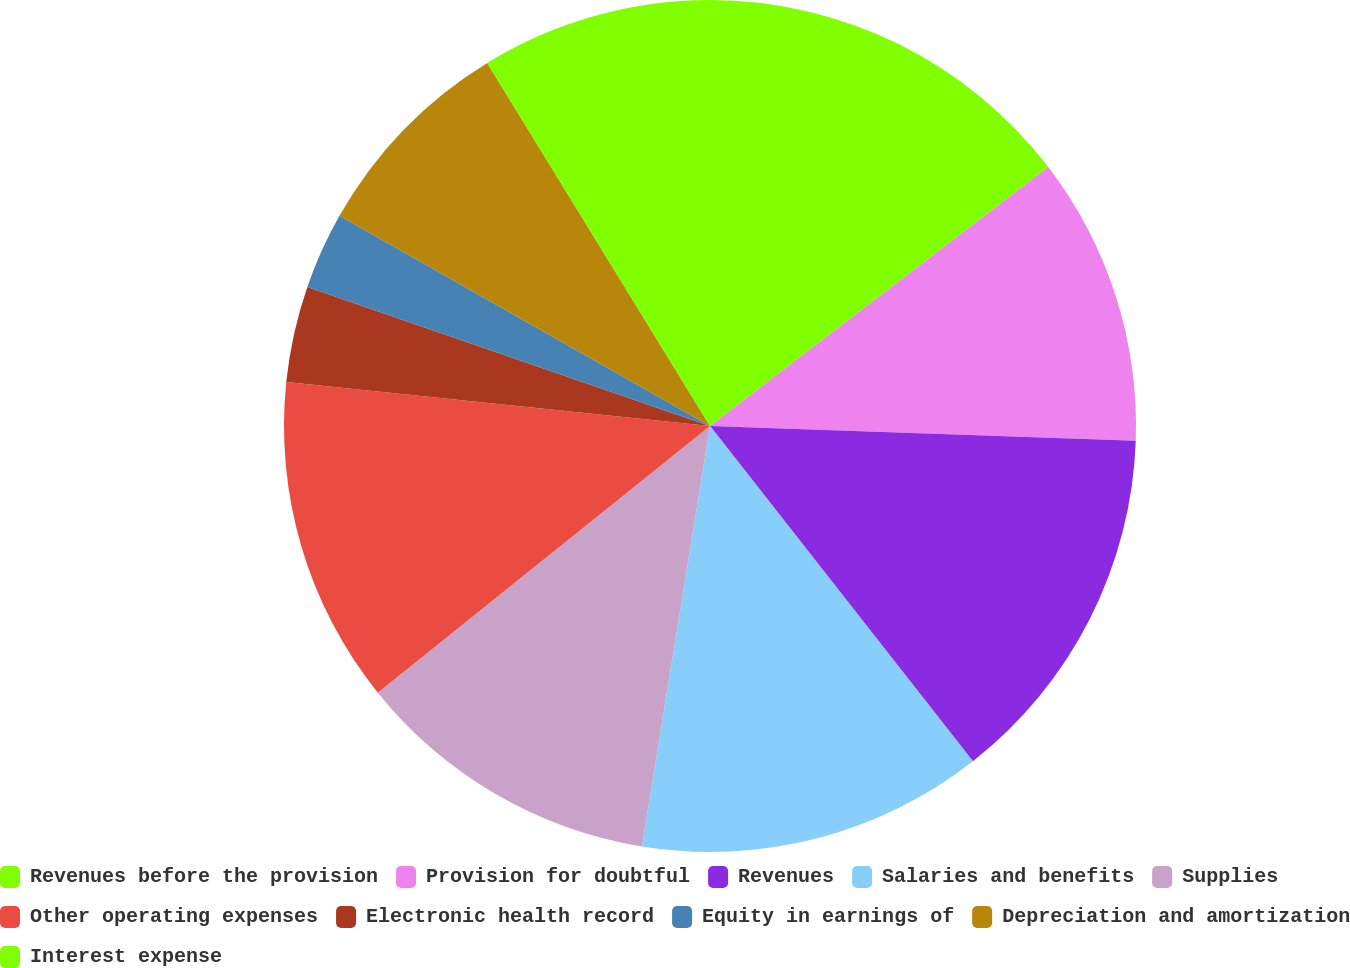Convert chart. <chart><loc_0><loc_0><loc_500><loc_500><pie_chart><fcel>Revenues before the provision<fcel>Provision for doubtful<fcel>Revenues<fcel>Salaries and benefits<fcel>Supplies<fcel>Other operating expenses<fcel>Electronic health record<fcel>Equity in earnings of<fcel>Depreciation and amortization<fcel>Interest expense<nl><fcel>14.6%<fcel>10.95%<fcel>13.87%<fcel>13.14%<fcel>11.68%<fcel>12.41%<fcel>3.65%<fcel>2.92%<fcel>8.03%<fcel>8.76%<nl></chart> 